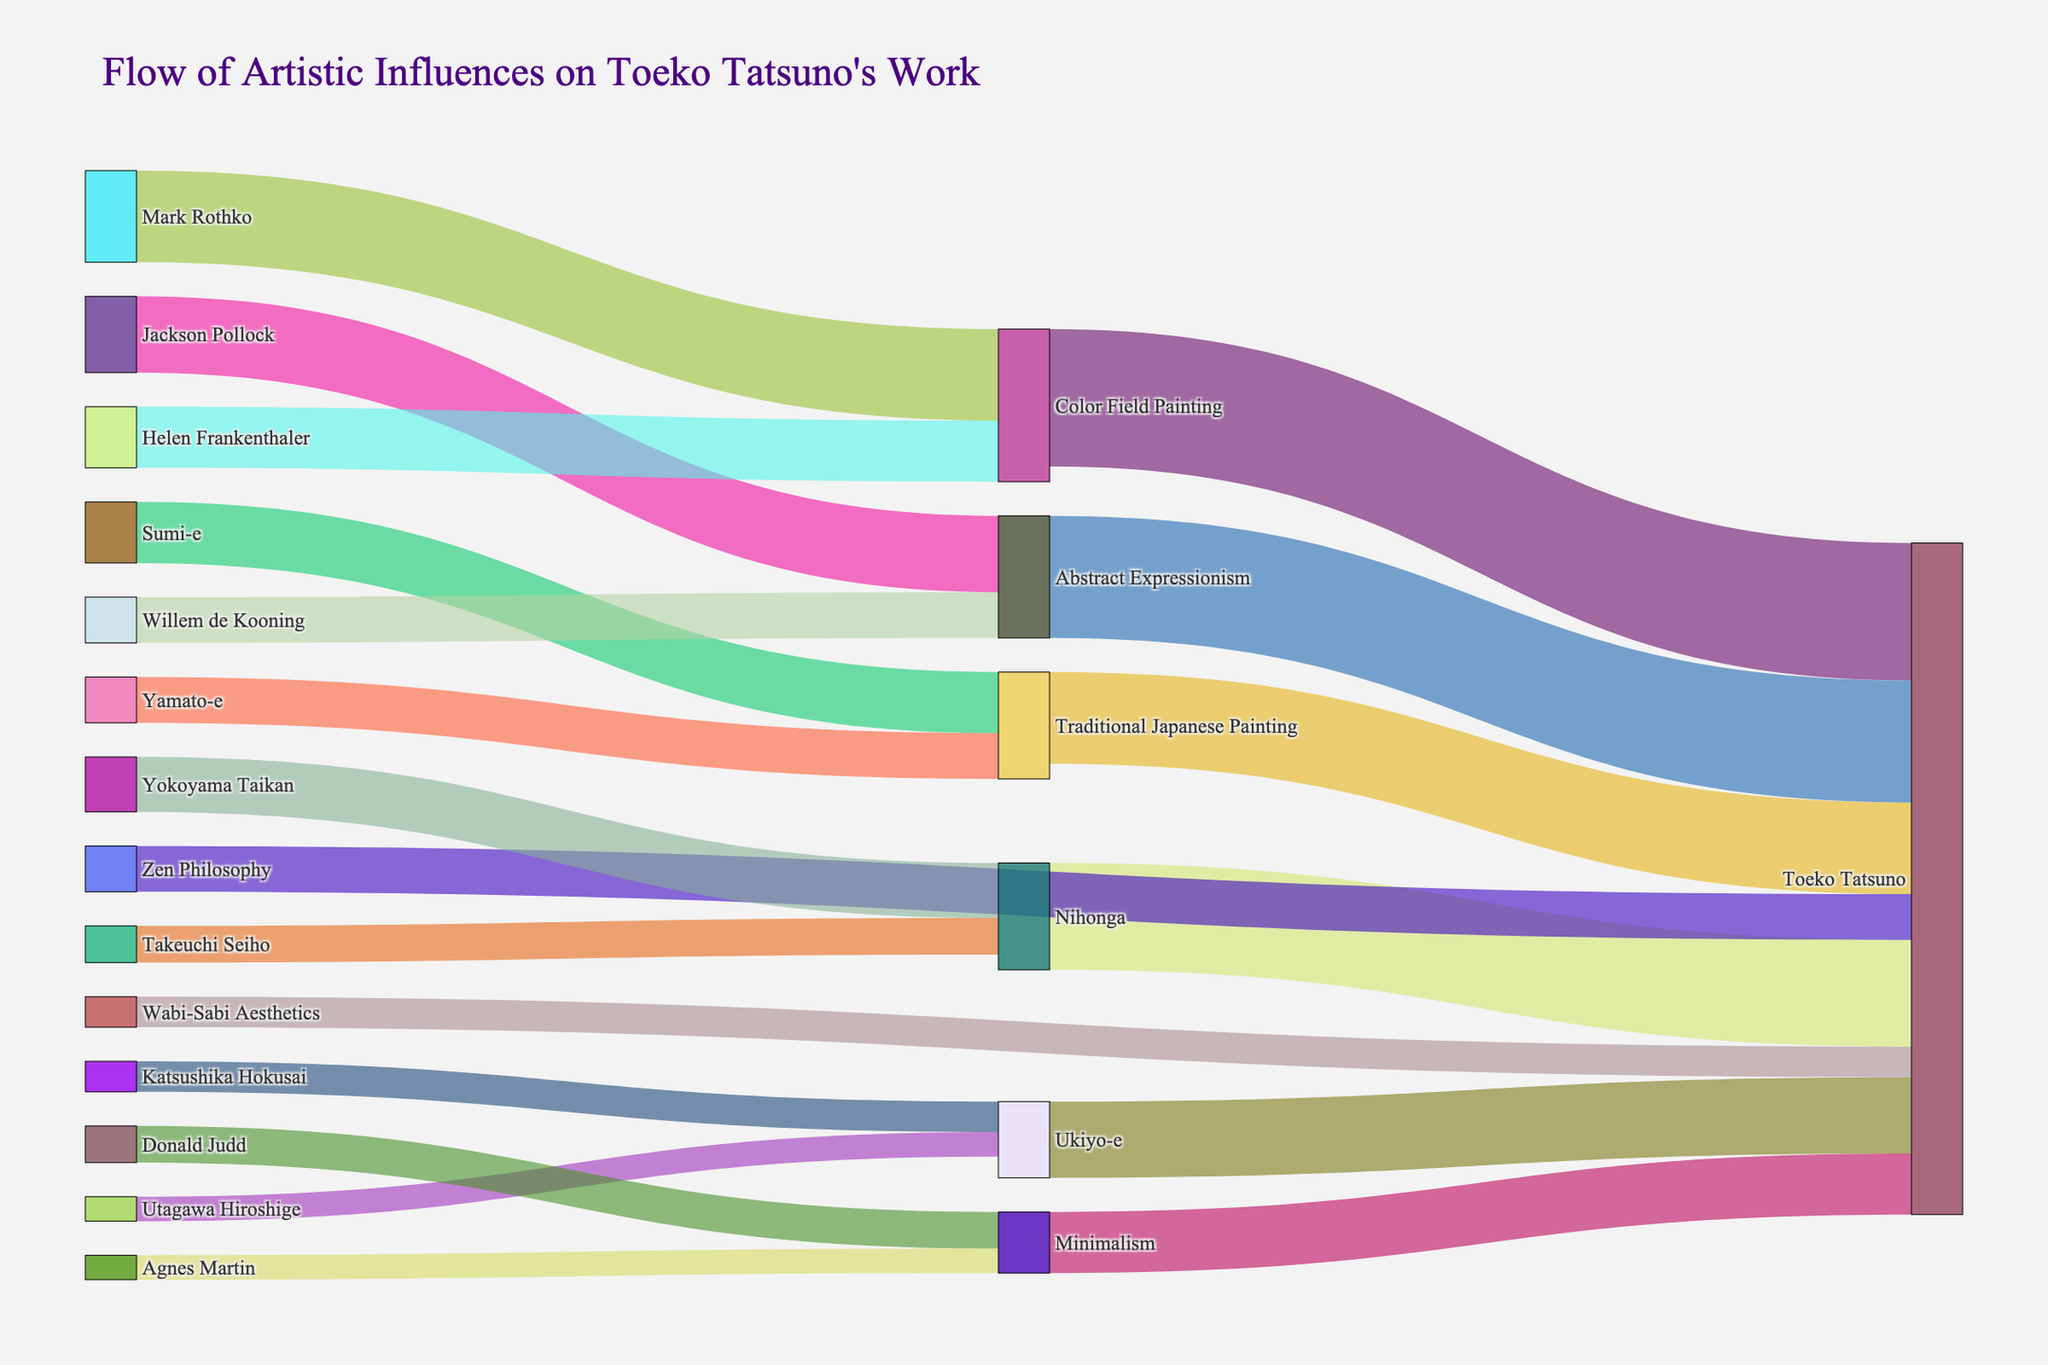what is the highest influence value on Toeko Tatsuno's work? The highest influence can be determined by looking at the values represented by the links directly connected to Toeko Tatsuno's node and selecting the maximum one. The highest value among these links is 45 from Color Field Painting.
Answer: 45 What are the three artistic influences directly connected to Traditional Japanese Painting? The three influences directly connected to Traditional Japanese Painting are Sumi-e and Yamato-e. By observing the nodes next to the Traditional Japanese Painting node, we find these connections.
Answer: Sumi-e, Yamato-e Which influence category has a higher influence on Toeko Tatsuno, Abstract Expressionism or Minimalism? By comparing the influence values, Abstract Expressionism has a value of 40 while Minimalism has a value of 20. Since 40 is greater than 20, Abstract Expressionism has a higher influence.
Answer: Abstract Expressionism What is the total influence from all traditional Japanese art forms on Toeko Tatsuno's work? Summing up the values from Traditional Japanese Painting (30), Ukiyo-e (25), Nihonga (35), and their respective sub-influences, we get 30 + 25 + 35 = 90.
Answer: 90 Which single artist has the largest influence on the Ukiyo-e style? By examining the links connected to Ukiyo-e, Katsushika Hokusai has a value of 10 and Utagawa Hiroshige has a value of 8. Since 10 is greater, Katsushika Hokusai has the largest influence on Ukiyo-e.
Answer: Katsushika Hokusai How does the influence of Wabi-Sabi Aesthetics compare to Zen Philosophy on Toeko Tatsuno's work? Wabi-Sabi Aesthetics has a value of 10 and Zen Philosophy has a value of 15. Comparing these, Zen Philosophy has a larger influence since 15 is greater than 10.
Answer: Zen Philosophy What is the combined influence of Jackson Pollock and Willem de Kooning on Toeko Tatsuno through Abstract Expressionism? Jackson Pollock's influence is 25 and Willem de Kooning's is 15. Adding these gives us a total influence of 25 + 15 = 40.
Answer: 40 Which influence has the smallest value connected directly to Toeko Tatsuno? By scanning the values, the smallest influence directly connected to Toeko Tatsuno is from Wabi-Sabi Aesthetics, which has a value of 10.
Answer: Wabi-Sabi Aesthetics 